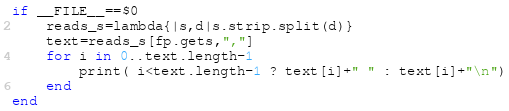<code> <loc_0><loc_0><loc_500><loc_500><_Ruby_>if __FILE__==$0
	reads_s=lambda{|s,d|s.strip.split(d)}
	text=reads_s[fp.gets,","]
	for i in 0..text.length-1
		print( i<text.length-1 ? text[i]+" " : text[i]+"\n")
	end
end</code> 